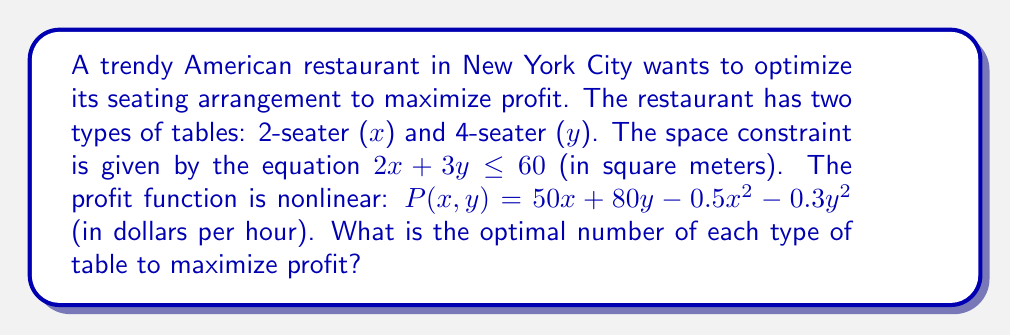Solve this math problem. To solve this nonlinear programming problem, we'll use the method of Lagrange multipliers:

1) Define the Lagrangian function:
   $$L(x,y,\lambda) = 50x + 80y - 0.5x^2 - 0.3y^2 - \lambda(2x + 3y - 60)$$

2) Take partial derivatives and set them to zero:
   $$\frac{\partial L}{\partial x} = 50 - x - 2\lambda = 0$$
   $$\frac{\partial L}{\partial y} = 80 - 0.6y - 3\lambda = 0$$
   $$\frac{\partial L}{\partial \lambda} = 2x + 3y - 60 = 0$$

3) From the first equation:
   $$x = 50 - 2\lambda$$

4) From the second equation:
   $$y = \frac{80 - 3\lambda}{0.6} = \frac{400 - 15\lambda}{3}$$

5) Substitute these into the third equation:
   $$2(50 - 2\lambda) + 3(\frac{400 - 15\lambda}{3}) - 60 = 0$$
   $$100 - 4\lambda + 400 - 15\lambda - 60 = 0$$
   $$440 - 19\lambda = 60$$
   $$380 = 19\lambda$$
   $$\lambda = 20$$

6) Substitute $\lambda = 20$ back into the equations for $x$ and $y$:
   $$x = 50 - 2(20) = 10$$
   $$y = \frac{400 - 15(20)}{3} = \frac{100}{3} \approx 33.33$$

7) Since we can't have fractional tables, we round down to 33 4-seater tables.

8) Check the constraint:
   $$2(10) + 3(33) = 20 + 99 = 119 \leq 60$$
   This violates the constraint, so we need to adjust.

9) Reduce $y$ to 32:
   $$2(10) + 3(32) = 20 + 96 = 116 \leq 60$$
   Still violates the constraint.

10) Reduce $y$ to 13:
    $$2(10) + 3(13) = 20 + 39 = 59 \leq 60$$
    This satisfies the constraint.
Answer: 10 2-seater tables and 13 4-seater tables 